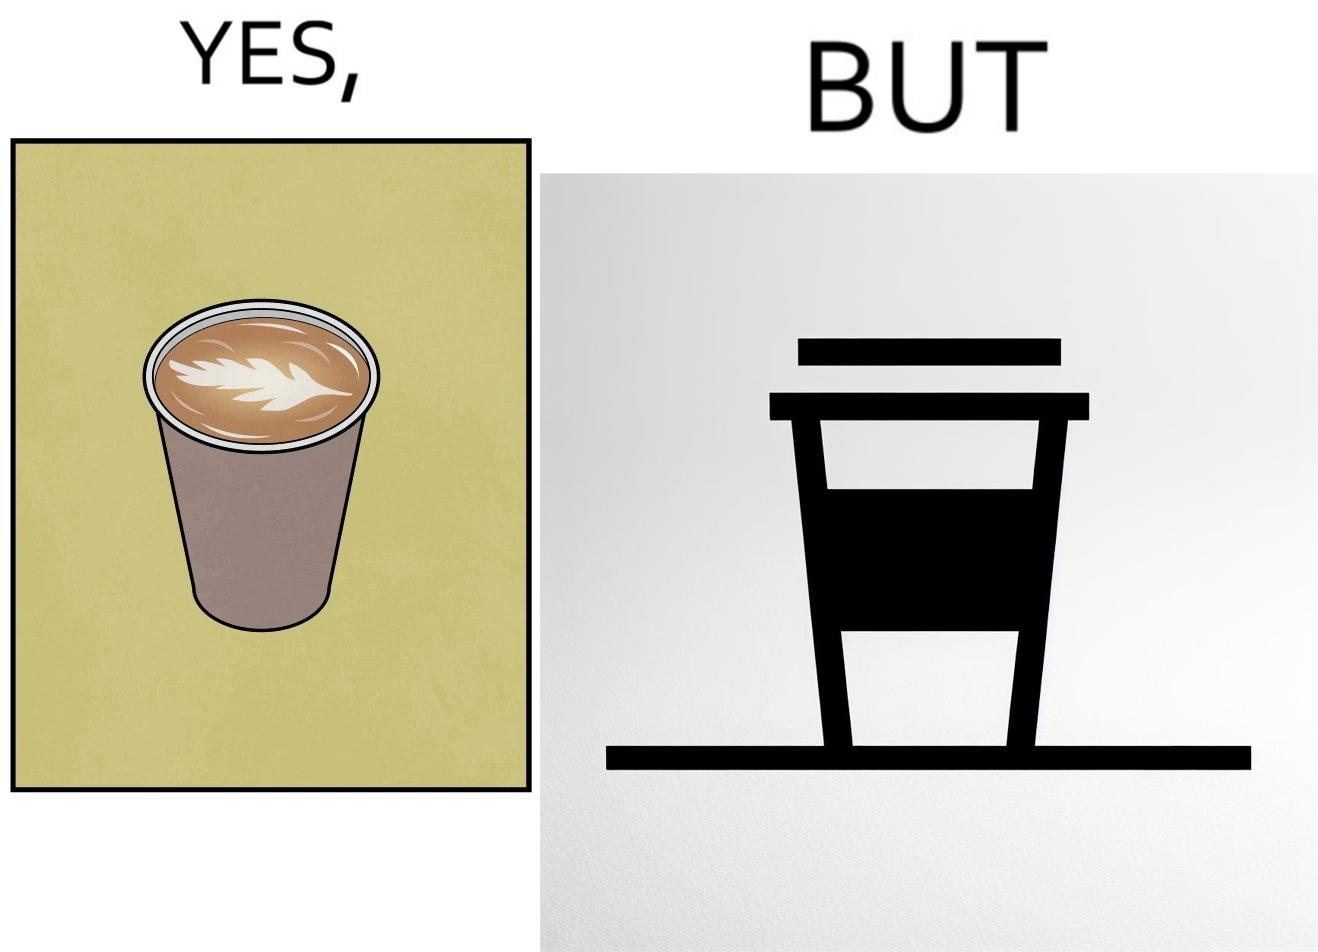What is the satirical meaning behind this image? The images are funny since it shows how someone has put effort into a cup of coffee to do latte art on it only for it to be invisible after a lid is put on the coffee cup before serving to a customer 